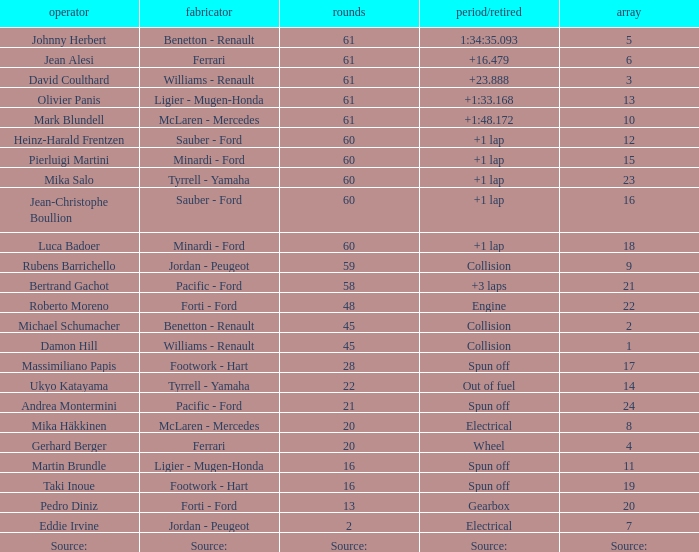What's the time/retired for constructor source:? Source:. 